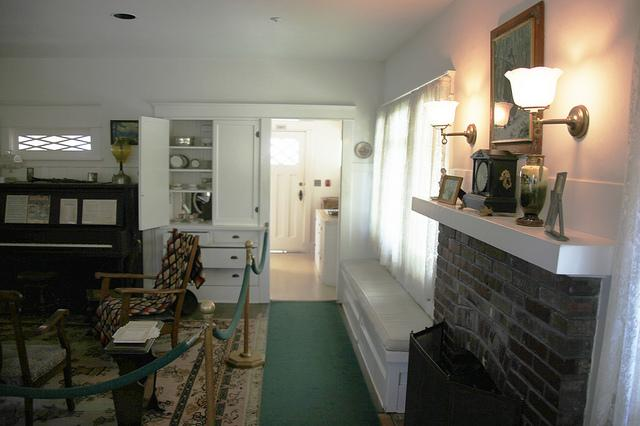What item is under the bright lights attached to the wall? Please explain your reasoning. fireplace. The item is the fireplace. 